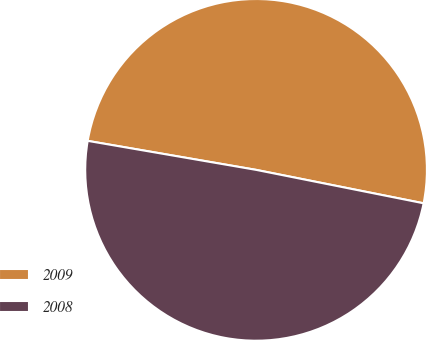Convert chart. <chart><loc_0><loc_0><loc_500><loc_500><pie_chart><fcel>2009<fcel>2008<nl><fcel>50.42%<fcel>49.58%<nl></chart> 